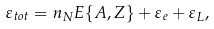<formula> <loc_0><loc_0><loc_500><loc_500>\varepsilon _ { t o t } = n _ { N } E \{ A , Z \} + \varepsilon _ { e } + \varepsilon _ { L } ,</formula> 